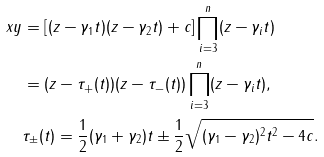<formula> <loc_0><loc_0><loc_500><loc_500>x y & = \left [ ( z - \gamma _ { 1 } t ) ( z - \gamma _ { 2 } t ) + c \right ] \prod _ { i = 3 } ^ { n } ( z - \gamma _ { i } t ) \\ & = ( z - \tau _ { + } ( t ) ) ( z - \tau _ { - } ( t ) ) \prod _ { i = 3 } ^ { n } ( z - \gamma _ { i } t ) , \\ & \tau _ { \pm } ( t ) = \frac { 1 } { 2 } ( \gamma _ { 1 } + \gamma _ { 2 } ) t \pm \frac { 1 } { 2 } \sqrt { ( \gamma _ { 1 } - \gamma _ { 2 } ) ^ { 2 } t ^ { 2 } - 4 c } .</formula> 